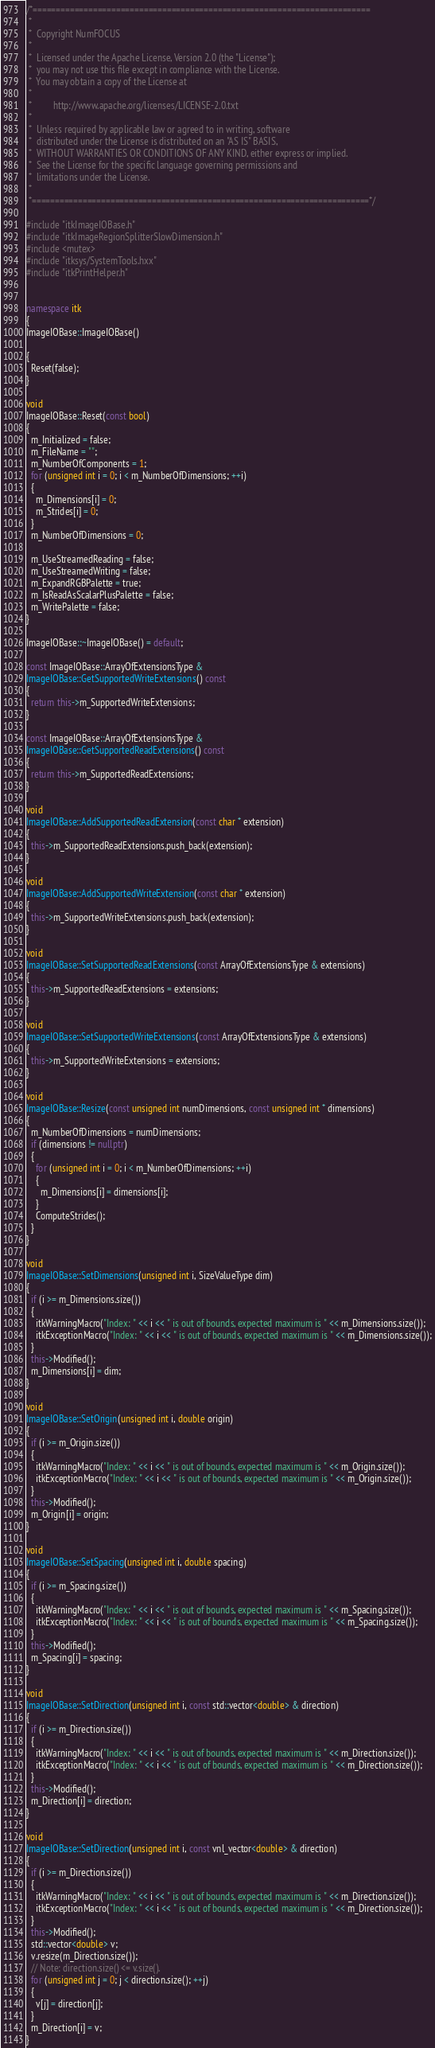Convert code to text. <code><loc_0><loc_0><loc_500><loc_500><_C++_>/*=========================================================================
 *
 *  Copyright NumFOCUS
 *
 *  Licensed under the Apache License, Version 2.0 (the "License");
 *  you may not use this file except in compliance with the License.
 *  You may obtain a copy of the License at
 *
 *         http://www.apache.org/licenses/LICENSE-2.0.txt
 *
 *  Unless required by applicable law or agreed to in writing, software
 *  distributed under the License is distributed on an "AS IS" BASIS,
 *  WITHOUT WARRANTIES OR CONDITIONS OF ANY KIND, either express or implied.
 *  See the License for the specific language governing permissions and
 *  limitations under the License.
 *
 *=========================================================================*/

#include "itkImageIOBase.h"
#include "itkImageRegionSplitterSlowDimension.h"
#include <mutex>
#include "itksys/SystemTools.hxx"
#include "itkPrintHelper.h"


namespace itk
{
ImageIOBase::ImageIOBase()

{
  Reset(false);
}

void
ImageIOBase::Reset(const bool)
{
  m_Initialized = false;
  m_FileName = "";
  m_NumberOfComponents = 1;
  for (unsigned int i = 0; i < m_NumberOfDimensions; ++i)
  {
    m_Dimensions[i] = 0;
    m_Strides[i] = 0;
  }
  m_NumberOfDimensions = 0;

  m_UseStreamedReading = false;
  m_UseStreamedWriting = false;
  m_ExpandRGBPalette = true;
  m_IsReadAsScalarPlusPalette = false;
  m_WritePalette = false;
}

ImageIOBase::~ImageIOBase() = default;

const ImageIOBase::ArrayOfExtensionsType &
ImageIOBase::GetSupportedWriteExtensions() const
{
  return this->m_SupportedWriteExtensions;
}

const ImageIOBase::ArrayOfExtensionsType &
ImageIOBase::GetSupportedReadExtensions() const
{
  return this->m_SupportedReadExtensions;
}

void
ImageIOBase::AddSupportedReadExtension(const char * extension)
{
  this->m_SupportedReadExtensions.push_back(extension);
}

void
ImageIOBase::AddSupportedWriteExtension(const char * extension)
{
  this->m_SupportedWriteExtensions.push_back(extension);
}

void
ImageIOBase::SetSupportedReadExtensions(const ArrayOfExtensionsType & extensions)
{
  this->m_SupportedReadExtensions = extensions;
}

void
ImageIOBase::SetSupportedWriteExtensions(const ArrayOfExtensionsType & extensions)
{
  this->m_SupportedWriteExtensions = extensions;
}

void
ImageIOBase::Resize(const unsigned int numDimensions, const unsigned int * dimensions)
{
  m_NumberOfDimensions = numDimensions;
  if (dimensions != nullptr)
  {
    for (unsigned int i = 0; i < m_NumberOfDimensions; ++i)
    {
      m_Dimensions[i] = dimensions[i];
    }
    ComputeStrides();
  }
}

void
ImageIOBase::SetDimensions(unsigned int i, SizeValueType dim)
{
  if (i >= m_Dimensions.size())
  {
    itkWarningMacro("Index: " << i << " is out of bounds, expected maximum is " << m_Dimensions.size());
    itkExceptionMacro("Index: " << i << " is out of bounds, expected maximum is " << m_Dimensions.size());
  }
  this->Modified();
  m_Dimensions[i] = dim;
}

void
ImageIOBase::SetOrigin(unsigned int i, double origin)
{
  if (i >= m_Origin.size())
  {
    itkWarningMacro("Index: " << i << " is out of bounds, expected maximum is " << m_Origin.size());
    itkExceptionMacro("Index: " << i << " is out of bounds, expected maximum is " << m_Origin.size());
  }
  this->Modified();
  m_Origin[i] = origin;
}

void
ImageIOBase::SetSpacing(unsigned int i, double spacing)
{
  if (i >= m_Spacing.size())
  {
    itkWarningMacro("Index: " << i << " is out of bounds, expected maximum is " << m_Spacing.size());
    itkExceptionMacro("Index: " << i << " is out of bounds, expected maximum is " << m_Spacing.size());
  }
  this->Modified();
  m_Spacing[i] = spacing;
}

void
ImageIOBase::SetDirection(unsigned int i, const std::vector<double> & direction)
{
  if (i >= m_Direction.size())
  {
    itkWarningMacro("Index: " << i << " is out of bounds, expected maximum is " << m_Direction.size());
    itkExceptionMacro("Index: " << i << " is out of bounds, expected maximum is " << m_Direction.size());
  }
  this->Modified();
  m_Direction[i] = direction;
}

void
ImageIOBase::SetDirection(unsigned int i, const vnl_vector<double> & direction)
{
  if (i >= m_Direction.size())
  {
    itkWarningMacro("Index: " << i << " is out of bounds, expected maximum is " << m_Direction.size());
    itkExceptionMacro("Index: " << i << " is out of bounds, expected maximum is " << m_Direction.size());
  }
  this->Modified();
  std::vector<double> v;
  v.resize(m_Direction.size());
  // Note: direction.size() <= v.size().
  for (unsigned int j = 0; j < direction.size(); ++j)
  {
    v[j] = direction[j];
  }
  m_Direction[i] = v;
}
</code> 